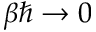<formula> <loc_0><loc_0><loc_500><loc_500>\beta \hbar { \to } 0</formula> 